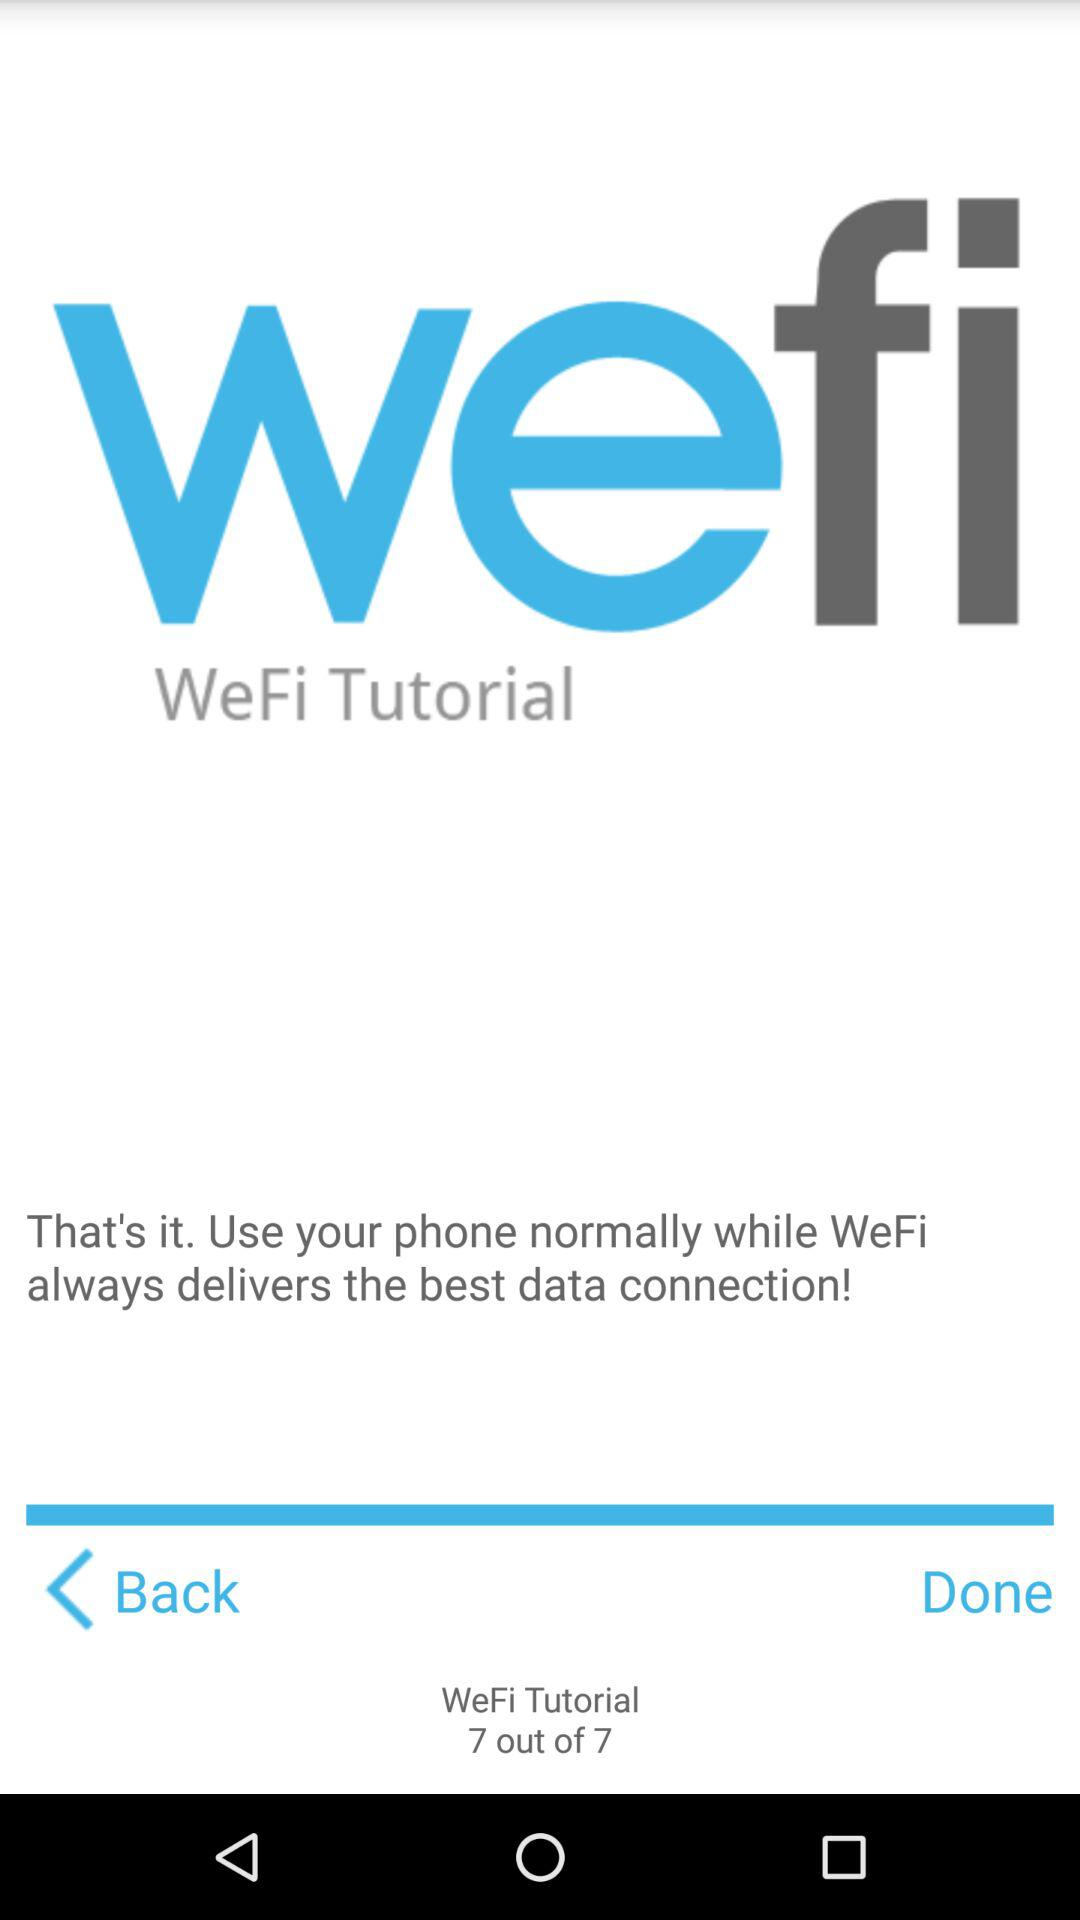How many steps are there in the tutorial?
Answer the question using a single word or phrase. 7 